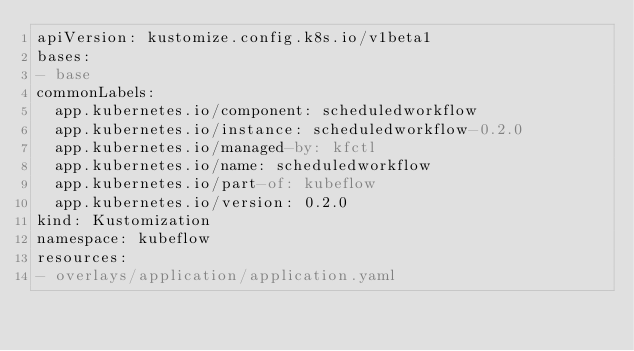<code> <loc_0><loc_0><loc_500><loc_500><_YAML_>apiVersion: kustomize.config.k8s.io/v1beta1
bases:
- base
commonLabels:
  app.kubernetes.io/component: scheduledworkflow
  app.kubernetes.io/instance: scheduledworkflow-0.2.0
  app.kubernetes.io/managed-by: kfctl
  app.kubernetes.io/name: scheduledworkflow
  app.kubernetes.io/part-of: kubeflow
  app.kubernetes.io/version: 0.2.0
kind: Kustomization
namespace: kubeflow
resources:
- overlays/application/application.yaml
</code> 